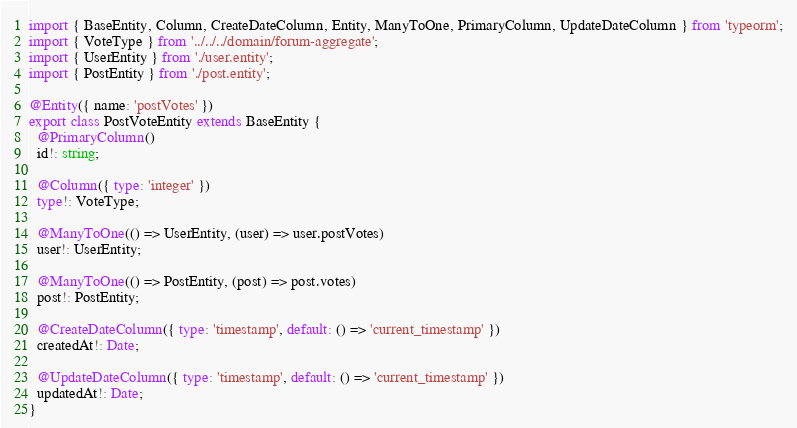Convert code to text. <code><loc_0><loc_0><loc_500><loc_500><_TypeScript_>import { BaseEntity, Column, CreateDateColumn, Entity, ManyToOne, PrimaryColumn, UpdateDateColumn } from 'typeorm';
import { VoteType } from '../../../domain/forum-aggregate';
import { UserEntity } from './user.entity';
import { PostEntity } from './post.entity';

@Entity({ name: 'postVotes' })
export class PostVoteEntity extends BaseEntity {
  @PrimaryColumn()
  id!: string;

  @Column({ type: 'integer' })
  type!: VoteType;

  @ManyToOne(() => UserEntity, (user) => user.postVotes)
  user!: UserEntity;

  @ManyToOne(() => PostEntity, (post) => post.votes)
  post!: PostEntity;

  @CreateDateColumn({ type: 'timestamp', default: () => 'current_timestamp' })
  createdAt!: Date;

  @UpdateDateColumn({ type: 'timestamp', default: () => 'current_timestamp' })
  updatedAt!: Date;
}
</code> 